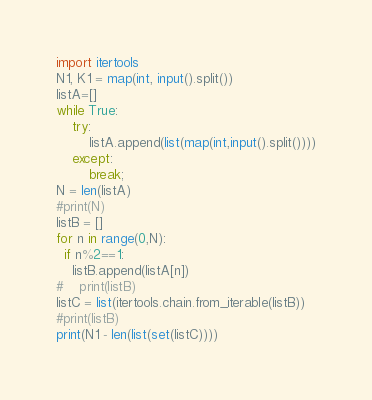Convert code to text. <code><loc_0><loc_0><loc_500><loc_500><_Python_>import itertools
N1, K1 = map(int, input().split())
listA=[]
while True:
    try:
        listA.append(list(map(int,input().split())))
    except:
        break;
N = len(listA)
#print(N)
listB = []
for n in range(0,N):
  if n%2==1:
    listB.append(listA[n])
#    print(listB)
listC = list(itertools.chain.from_iterable(listB))
#print(listB)
print(N1 - len(list(set(listC))))</code> 